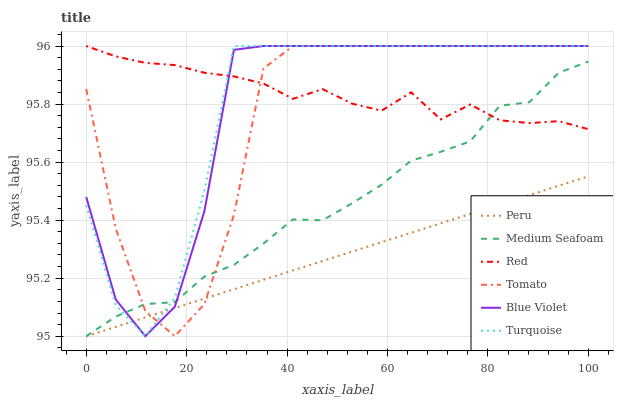Does Peru have the minimum area under the curve?
Answer yes or no. Yes. Does Red have the maximum area under the curve?
Answer yes or no. Yes. Does Turquoise have the minimum area under the curve?
Answer yes or no. No. Does Turquoise have the maximum area under the curve?
Answer yes or no. No. Is Peru the smoothest?
Answer yes or no. Yes. Is Tomato the roughest?
Answer yes or no. Yes. Is Turquoise the smoothest?
Answer yes or no. No. Is Turquoise the roughest?
Answer yes or no. No. Does Turquoise have the lowest value?
Answer yes or no. No. Does Peru have the highest value?
Answer yes or no. No. Is Peru less than Red?
Answer yes or no. Yes. Is Red greater than Peru?
Answer yes or no. Yes. Does Peru intersect Red?
Answer yes or no. No. 